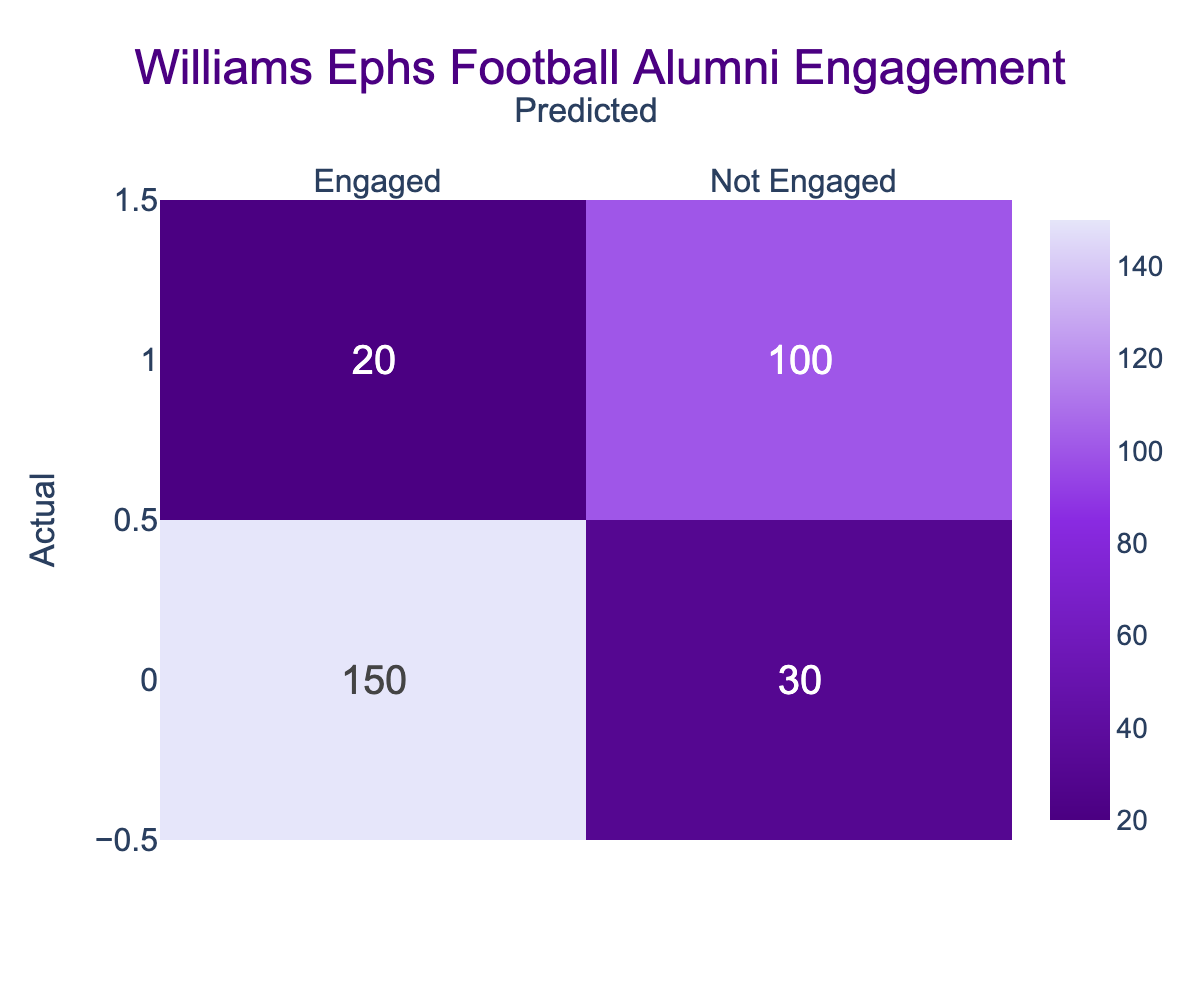What is the total number of alumni who were engaged? To find the total number of engaged alumni, we look at the 'Engaged' row and sum the values in that row: 150 (Engaged) + 30 (Not Engaged) = 180.
Answer: 180 How many alumni were predicted to be not engaged but were actually engaged? From the confusion matrix, in the 'Not Engaged' row under 'Engaged', we have 20. This is the count of alumni who were predicted as not engaged but were actually engaged.
Answer: 20 What is the ratio of alumni predicted as engaged to those predicted as not engaged? To find the ratio, we add the numbers in the 'Engaged' column: 150 + 20 = 170 (predicted engaged) and the 'Not Engaged' column: 30 + 100 = 130 (predicted not engaged). The ratio is 170:130, which simplifies to 17:13.
Answer: 17:13 Did more alumni actually engage than not engage? To answer this, we compare the total engaged (180) with the total not engaged (30 + 100 = 130). Since 180 is greater than 130, the answer is yes.
Answer: Yes What is the total number of alumni who were not engaged regardless of prediction? We calculate the total number of alumni who were not engaged by looking at the 'Not Engaged' row: 30 (predicted as engaged) + 100 (predicted as not engaged) = 130.
Answer: 130 What percentage of the total alumni were correctly predicted to be engaged? To find this, we need the number of true positives (150) and the total number of alumni: 150 (correctly predicted engaged) + 30 + 20 + 100 = 300 (total). The percentage of correctly predicted engaged is (150/300) * 100 = 50%.
Answer: 50% How many alumni who were actually not engaged did we incorrectly predict to be engaged? In the 'Engaged' row under 'Not Engaged', we have 30 alumni. This indicates the count of alumni who were not engaged but were wrongly predicted as engaged.
Answer: 30 What is the difference between actual engaged alumni and actual not engaged alumni? The actual engaged alumni count is 150, and the actual not engaged count is 120 (30 + 100). Thus, the difference is 150 - 120 = 30.
Answer: 30 What proportion of the predicted engaged alumni were actually engaged? The predicted engaged alumni count is 170 (150 engaged + 20 not engaged). The proportion of alumni who were actually engaged is 150/170, which is approximately 0.882.
Answer: Approximately 0.882 